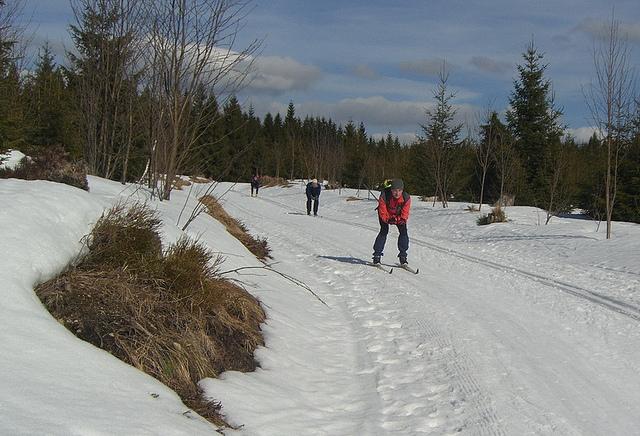Are they going up or down the hill?
Short answer required. Down. Is this a steep hill?
Quick response, please. No. What sport are they doing?
Write a very short answer. Skiing. 